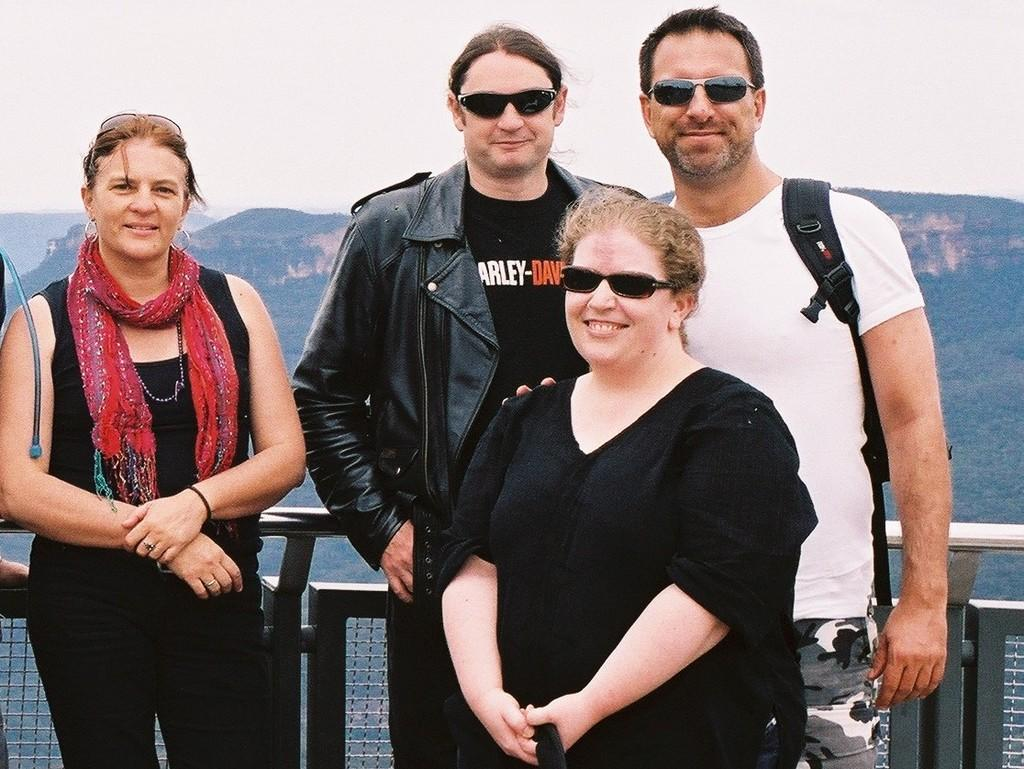What can be seen in the image involving people? There are persons standing in the image. What type of barrier is present in the image? There is a fence visible in the image. What type of vegetation is present in the image? There are trees in the image. What type of geographical feature is present in the image? There are mountains in the image. What part of the natural environment is visible in the image? The sky is visible in the image. What type of base can be seen in the image? There is no base present in the image. What type of trade is happening in the image? There is no trade happening in the image; it is a scene with people, a fence, trees, mountains, and the sky. 